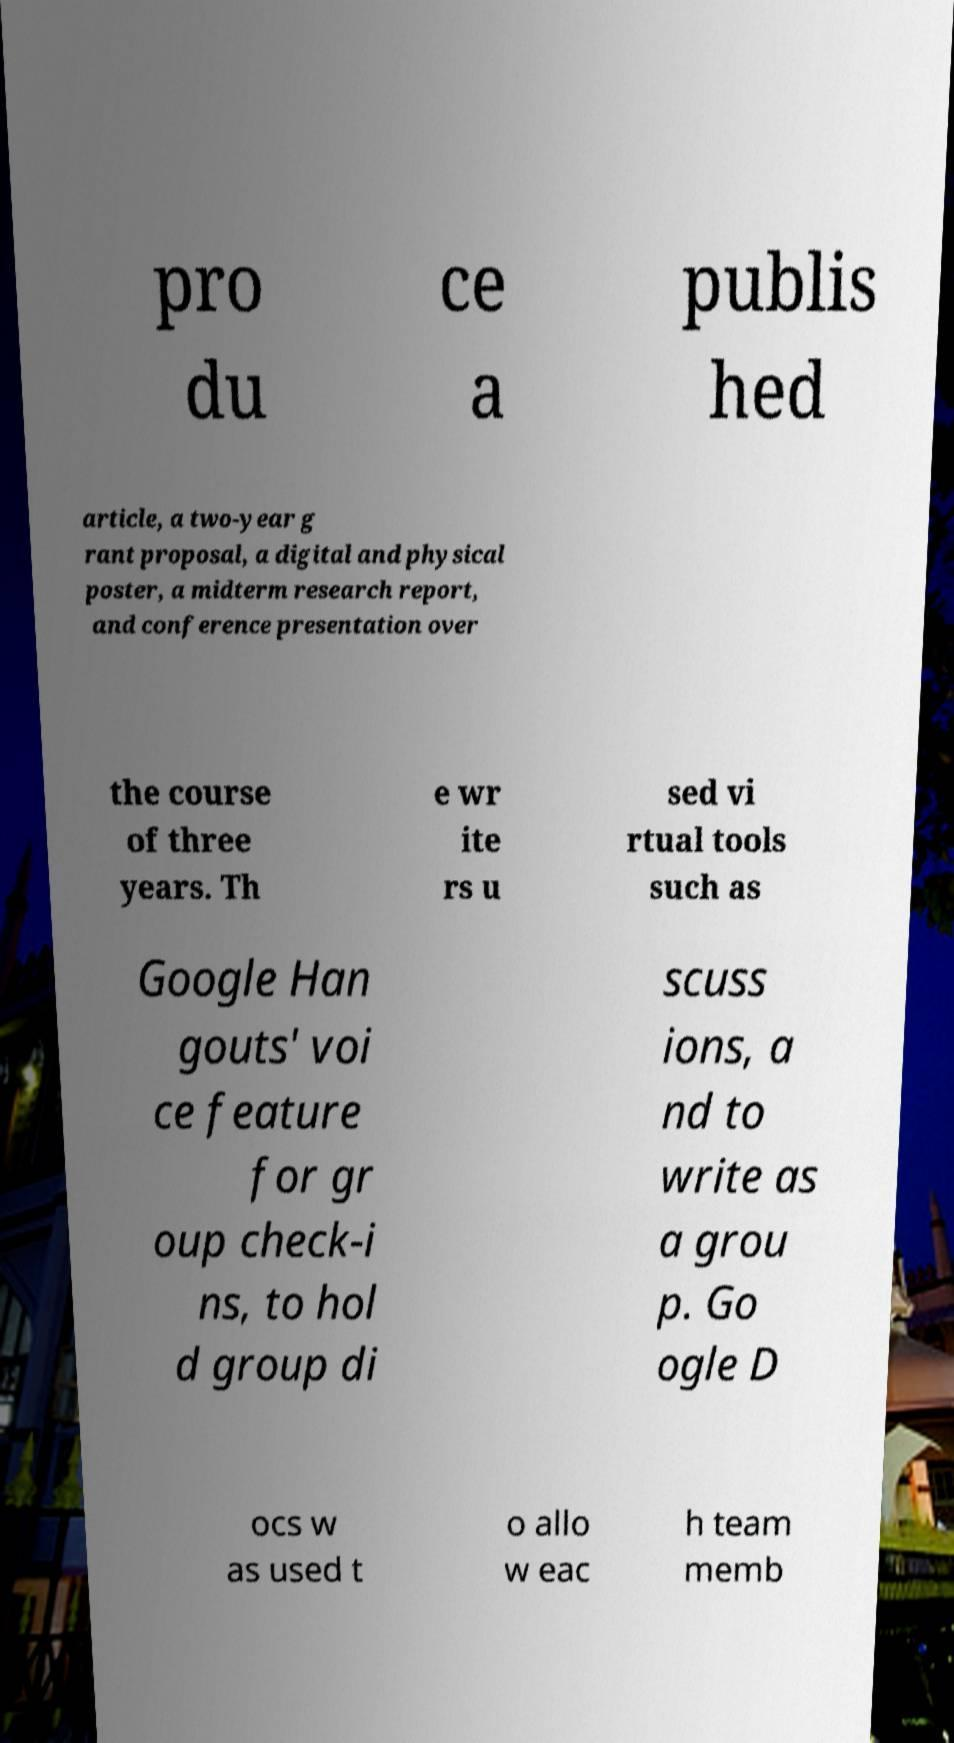There's text embedded in this image that I need extracted. Can you transcribe it verbatim? pro du ce a publis hed article, a two-year g rant proposal, a digital and physical poster, a midterm research report, and conference presentation over the course of three years. Th e wr ite rs u sed vi rtual tools such as Google Han gouts' voi ce feature for gr oup check-i ns, to hol d group di scuss ions, a nd to write as a grou p. Go ogle D ocs w as used t o allo w eac h team memb 